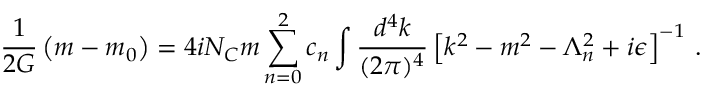<formula> <loc_0><loc_0><loc_500><loc_500>\frac { 1 } { 2 G } \left ( m - m _ { 0 } \right ) = 4 i N _ { C } m \sum _ { n = 0 } ^ { 2 } c _ { n } \int \frac { d ^ { 4 } k } { ( 2 \pi ) ^ { 4 } } \left [ k ^ { 2 } - m ^ { 2 } - \Lambda _ { n } ^ { 2 } + i \epsilon \right ] ^ { - 1 } \, .</formula> 